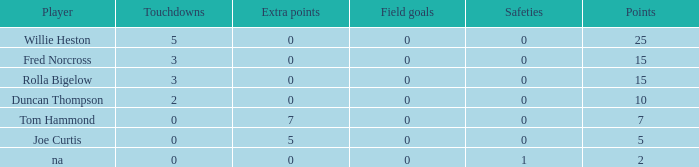How many Touchdowns have a Player of rolla bigelow, and an Extra points smaller than 0? None. 